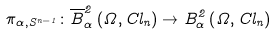<formula> <loc_0><loc_0><loc_500><loc_500>\pi _ { \alpha , S ^ { n - 1 } } \colon \overline { B } _ { \alpha } ^ { 2 } \left ( \Omega , C l _ { n } \right ) \rightarrow B _ { \alpha } ^ { 2 } \left ( \Omega , C l _ { n } \right )</formula> 